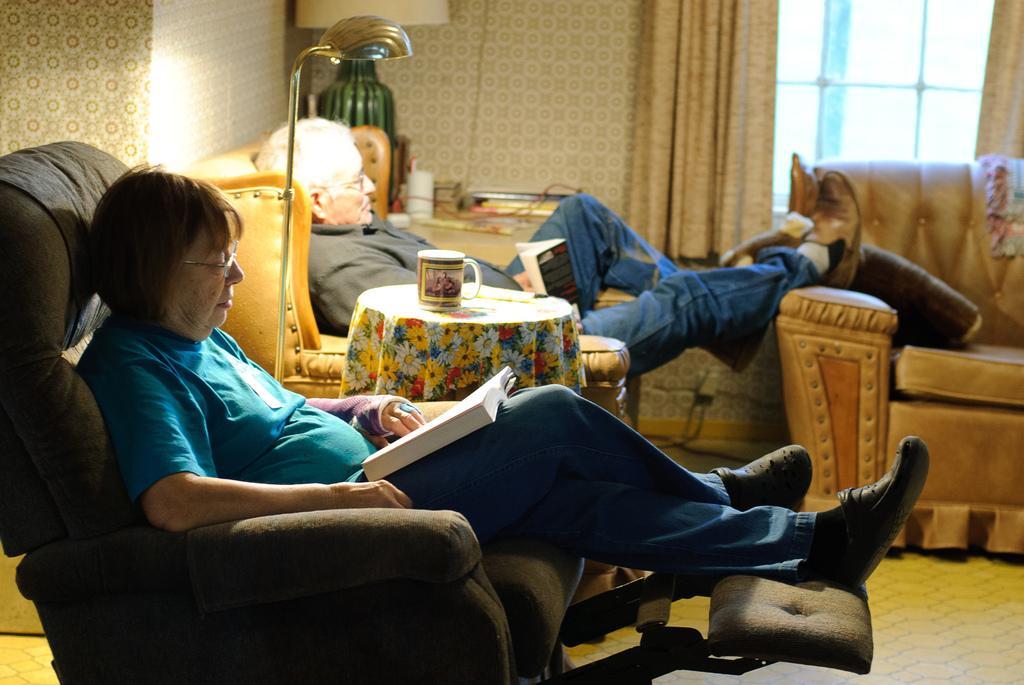Can you describe this image briefly? The image is inside the room. In the image there are two people sitting on couch, in middle there is a table on table we can see a cup and cloth with some flowers. On right side there is a window which is closed and curtains and in background there is a lamp,table,books. 